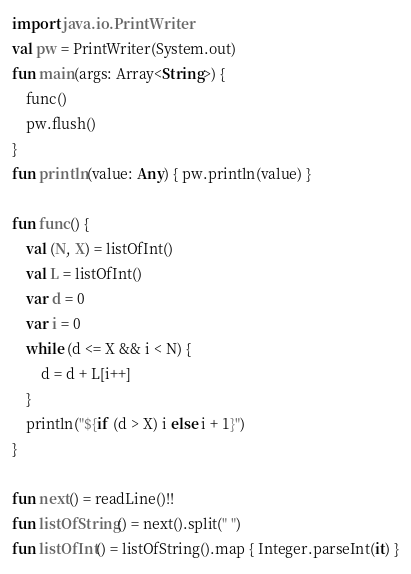<code> <loc_0><loc_0><loc_500><loc_500><_Kotlin_>import java.io.PrintWriter
val pw = PrintWriter(System.out)
fun main(args: Array<String>) {
    func()
    pw.flush()
}
fun println(value: Any) { pw.println(value) }

fun func() {
    val (N, X) = listOfInt()
    val L = listOfInt()
    var d = 0
    var i = 0
    while (d <= X && i < N) {
        d = d + L[i++]
    }
    println("${if (d > X) i else i + 1}")
}

fun next() = readLine()!!
fun listOfString() = next().split(" ")
fun listOfInt() = listOfString().map { Integer.parseInt(it) }
</code> 